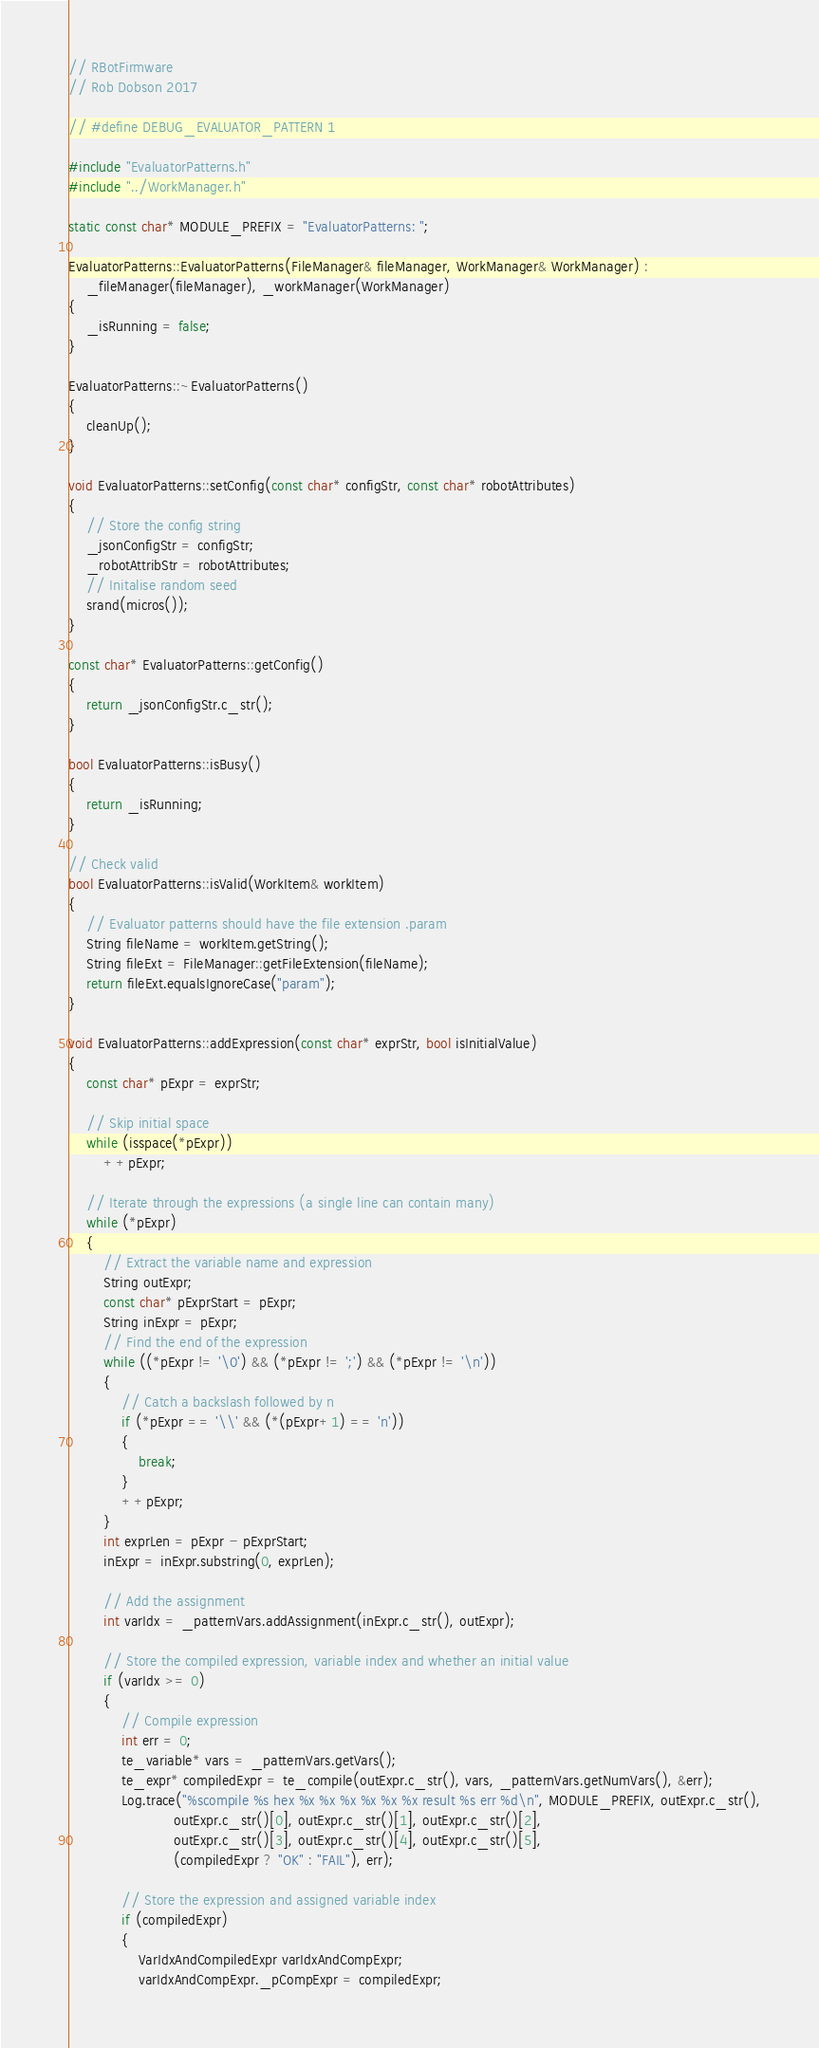<code> <loc_0><loc_0><loc_500><loc_500><_C++_>// RBotFirmware
// Rob Dobson 2017

// #define DEBUG_EVALUATOR_PATTERN 1

#include "EvaluatorPatterns.h"
#include "../WorkManager.h"

static const char* MODULE_PREFIX = "EvaluatorPatterns: ";

EvaluatorPatterns::EvaluatorPatterns(FileManager& fileManager, WorkManager& WorkManager) :
    _fileManager(fileManager), _workManager(WorkManager)
{
    _isRunning = false;
}

EvaluatorPatterns::~EvaluatorPatterns()
{
    cleanUp();
}

void EvaluatorPatterns::setConfig(const char* configStr, const char* robotAttributes)
{
    // Store the config string
    _jsonConfigStr = configStr;
    _robotAttribStr = robotAttributes;
    // Initalise random seed
    srand(micros());
}

const char* EvaluatorPatterns::getConfig()
{
    return _jsonConfigStr.c_str();
}

bool EvaluatorPatterns::isBusy()
{
    return _isRunning;
}

// Check valid
bool EvaluatorPatterns::isValid(WorkItem& workItem)
{
    // Evaluator patterns should have the file extension .param
    String fileName = workItem.getString();
    String fileExt = FileManager::getFileExtension(fileName);
    return fileExt.equalsIgnoreCase("param");
}

void EvaluatorPatterns::addExpression(const char* exprStr, bool isInitialValue)
{
    const char* pExpr = exprStr;

    // Skip initial space
    while (isspace(*pExpr))
        ++pExpr;

    // Iterate through the expressions (a single line can contain many)
    while (*pExpr)
    {
        // Extract the variable name and expression
        String outExpr;
        const char* pExprStart = pExpr;
        String inExpr = pExpr;
        // Find the end of the expression
        while ((*pExpr != '\0') && (*pExpr != ';') && (*pExpr != '\n'))
        {
            // Catch a backslash followed by n
            if (*pExpr == '\\' && (*(pExpr+1) == 'n'))
            {
                break;
            }
            ++pExpr;
        }
        int exprLen = pExpr - pExprStart;
        inExpr = inExpr.substring(0, exprLen);

        // Add the assignment
        int varIdx = _patternVars.addAssignment(inExpr.c_str(), outExpr);

        // Store the compiled expression, variable index and whether an initial value
        if (varIdx >= 0)
        {
            // Compile expression
            int err = 0;
            te_variable* vars = _patternVars.getVars();
            te_expr* compiledExpr = te_compile(outExpr.c_str(), vars, _patternVars.getNumVars(), &err);
            Log.trace("%scompile %s hex %x %x %x %x %x %x result %s err %d\n", MODULE_PREFIX, outExpr.c_str(),
                        outExpr.c_str()[0], outExpr.c_str()[1], outExpr.c_str()[2],
                        outExpr.c_str()[3], outExpr.c_str()[4], outExpr.c_str()[5],
                        (compiledExpr ? "OK" : "FAIL"), err);
 
            // Store the expression and assigned variable index
            if (compiledExpr)
            {
                VarIdxAndCompiledExpr varIdxAndCompExpr;
                varIdxAndCompExpr._pCompExpr = compiledExpr;</code> 